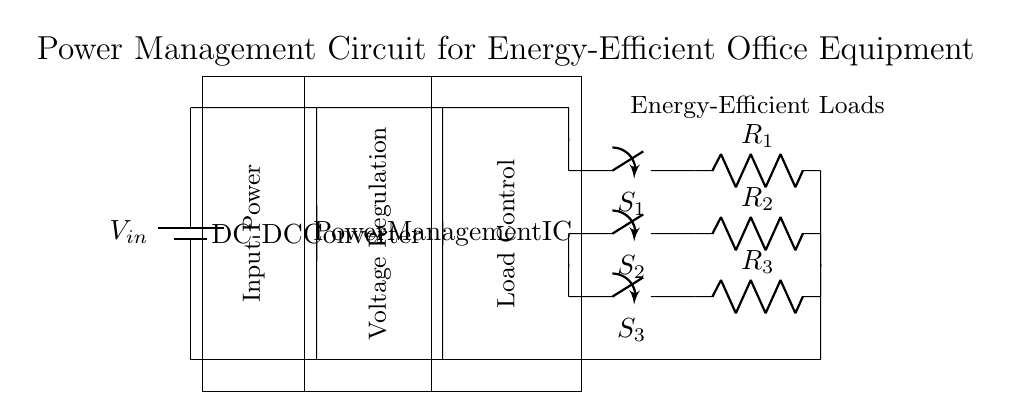What is the input power for the circuit? The input power is indicated by the battery symbol labeled as V in the circuit diagram. It shows that the power source supplies energy to the circuit.
Answer: V in What components are used for load control? The load control in the circuit consists of three closing switches labeled S1, S2, and S3, which can open or close the circuit to control the flow of electricity to the loads.
Answer: S1, S2, S3 How many loads are connected to the circuit? There are three loads connected to the circuit as represented by the resistors labeled R1, R2, and R3. Each load corresponds to one resistor, indicating the energy-efficient devices in the office equipment.
Answer: Three What does the DC-DC converter do in this circuit? The DC-DC converter is responsible for voltage regulation, which changes the input voltage level to a suitable output voltage required by the load. It ensures the voltage supplied to the load is stable and appropriate.
Answer: Voltage regulation What is the function of the power management IC? The power management integrated circuit (IC) is designed to control the power distribution among the loads, optimizing energy efficiency. It manages the output voltage and current to reduce power wastage during operation.
Answer: Optimize energy efficiency Which components represent energy-efficient loads? The energy-efficient loads are represented by resistors R1, R2, and R3, which symbolize the office equipment's energy consumption within the circuit. Each resistor indicates a separate load in operation.
Answer: R1, R2, R3 